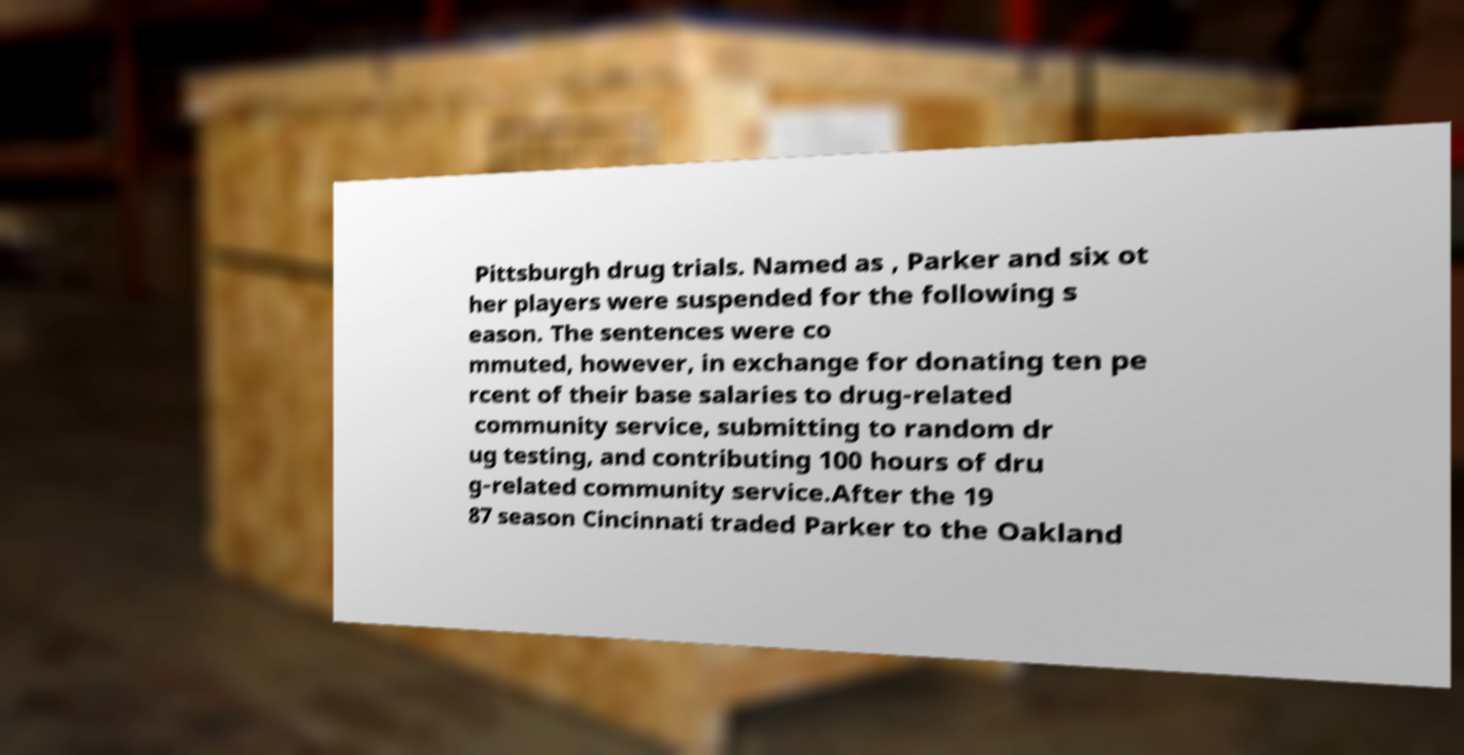Could you assist in decoding the text presented in this image and type it out clearly? Pittsburgh drug trials. Named as , Parker and six ot her players were suspended for the following s eason. The sentences were co mmuted, however, in exchange for donating ten pe rcent of their base salaries to drug-related community service, submitting to random dr ug testing, and contributing 100 hours of dru g-related community service.After the 19 87 season Cincinnati traded Parker to the Oakland 